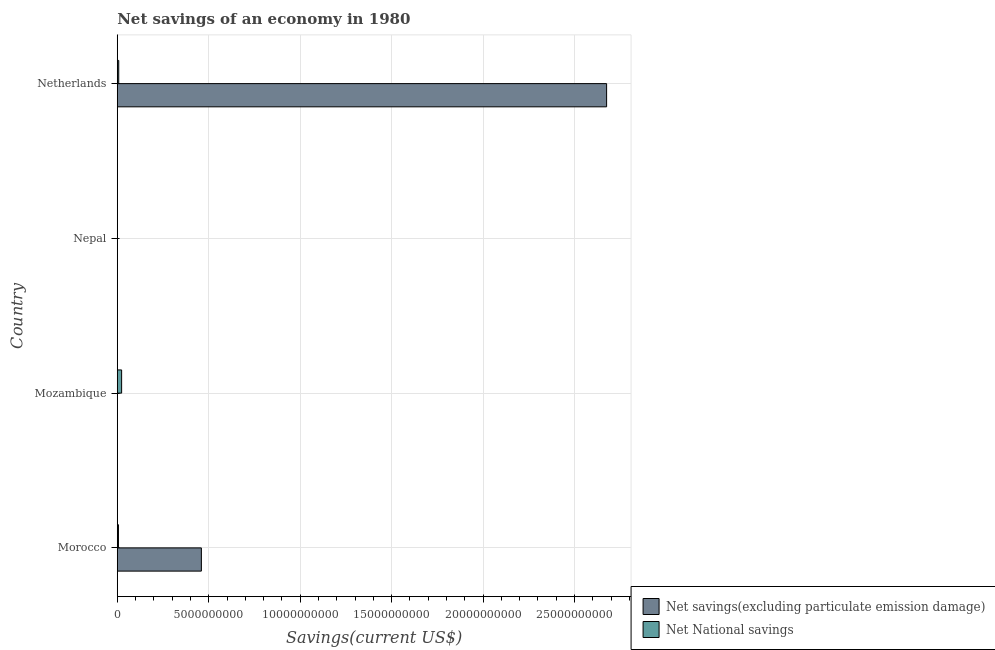Are the number of bars per tick equal to the number of legend labels?
Give a very brief answer. No. Are the number of bars on each tick of the Y-axis equal?
Offer a very short reply. No. What is the label of the 2nd group of bars from the top?
Your response must be concise. Nepal. In how many cases, is the number of bars for a given country not equal to the number of legend labels?
Offer a very short reply. 2. What is the net national savings in Nepal?
Your answer should be compact. 0. Across all countries, what is the maximum net national savings?
Offer a very short reply. 2.38e+08. Across all countries, what is the minimum net savings(excluding particulate emission damage)?
Your answer should be very brief. 0. What is the total net savings(excluding particulate emission damage) in the graph?
Offer a terse response. 3.14e+1. What is the difference between the net national savings in Mozambique and that in Netherlands?
Your response must be concise. 1.58e+08. What is the difference between the net savings(excluding particulate emission damage) in Morocco and the net national savings in Nepal?
Ensure brevity in your answer.  4.60e+09. What is the average net savings(excluding particulate emission damage) per country?
Ensure brevity in your answer.  7.84e+09. What is the difference between the net national savings and net savings(excluding particulate emission damage) in Morocco?
Offer a very short reply. -4.53e+09. In how many countries, is the net national savings greater than 13000000000 US$?
Give a very brief answer. 0. What is the ratio of the net national savings in Morocco to that in Mozambique?
Keep it short and to the point. 0.27. What is the difference between the highest and the second highest net national savings?
Give a very brief answer. 1.58e+08. What is the difference between the highest and the lowest net savings(excluding particulate emission damage)?
Keep it short and to the point. 2.68e+1. Is the sum of the net national savings in Mozambique and Netherlands greater than the maximum net savings(excluding particulate emission damage) across all countries?
Keep it short and to the point. No. How many bars are there?
Your answer should be compact. 5. Are all the bars in the graph horizontal?
Your answer should be very brief. Yes. How many countries are there in the graph?
Give a very brief answer. 4. What is the difference between two consecutive major ticks on the X-axis?
Offer a terse response. 5.00e+09. Does the graph contain any zero values?
Keep it short and to the point. Yes. Where does the legend appear in the graph?
Make the answer very short. Bottom right. How many legend labels are there?
Your response must be concise. 2. How are the legend labels stacked?
Give a very brief answer. Vertical. What is the title of the graph?
Your response must be concise. Net savings of an economy in 1980. What is the label or title of the X-axis?
Provide a succinct answer. Savings(current US$). What is the label or title of the Y-axis?
Your response must be concise. Country. What is the Savings(current US$) in Net savings(excluding particulate emission damage) in Morocco?
Your answer should be very brief. 4.60e+09. What is the Savings(current US$) of Net National savings in Morocco?
Provide a short and direct response. 6.43e+07. What is the Savings(current US$) in Net National savings in Mozambique?
Keep it short and to the point. 2.38e+08. What is the Savings(current US$) of Net savings(excluding particulate emission damage) in Nepal?
Offer a very short reply. 0. What is the Savings(current US$) of Net savings(excluding particulate emission damage) in Netherlands?
Make the answer very short. 2.68e+1. What is the Savings(current US$) in Net National savings in Netherlands?
Provide a succinct answer. 7.94e+07. Across all countries, what is the maximum Savings(current US$) of Net savings(excluding particulate emission damage)?
Provide a succinct answer. 2.68e+1. Across all countries, what is the maximum Savings(current US$) in Net National savings?
Keep it short and to the point. 2.38e+08. Across all countries, what is the minimum Savings(current US$) of Net savings(excluding particulate emission damage)?
Give a very brief answer. 0. Across all countries, what is the minimum Savings(current US$) in Net National savings?
Offer a very short reply. 0. What is the total Savings(current US$) of Net savings(excluding particulate emission damage) in the graph?
Make the answer very short. 3.14e+1. What is the total Savings(current US$) in Net National savings in the graph?
Give a very brief answer. 3.81e+08. What is the difference between the Savings(current US$) in Net National savings in Morocco and that in Mozambique?
Keep it short and to the point. -1.74e+08. What is the difference between the Savings(current US$) in Net savings(excluding particulate emission damage) in Morocco and that in Netherlands?
Your response must be concise. -2.22e+1. What is the difference between the Savings(current US$) in Net National savings in Morocco and that in Netherlands?
Offer a terse response. -1.50e+07. What is the difference between the Savings(current US$) in Net National savings in Mozambique and that in Netherlands?
Offer a terse response. 1.58e+08. What is the difference between the Savings(current US$) in Net savings(excluding particulate emission damage) in Morocco and the Savings(current US$) in Net National savings in Mozambique?
Your response must be concise. 4.36e+09. What is the difference between the Savings(current US$) of Net savings(excluding particulate emission damage) in Morocco and the Savings(current US$) of Net National savings in Netherlands?
Your answer should be very brief. 4.52e+09. What is the average Savings(current US$) of Net savings(excluding particulate emission damage) per country?
Your response must be concise. 7.84e+09. What is the average Savings(current US$) of Net National savings per country?
Provide a short and direct response. 9.54e+07. What is the difference between the Savings(current US$) of Net savings(excluding particulate emission damage) and Savings(current US$) of Net National savings in Morocco?
Your answer should be very brief. 4.53e+09. What is the difference between the Savings(current US$) of Net savings(excluding particulate emission damage) and Savings(current US$) of Net National savings in Netherlands?
Keep it short and to the point. 2.67e+1. What is the ratio of the Savings(current US$) of Net National savings in Morocco to that in Mozambique?
Your response must be concise. 0.27. What is the ratio of the Savings(current US$) in Net savings(excluding particulate emission damage) in Morocco to that in Netherlands?
Ensure brevity in your answer.  0.17. What is the ratio of the Savings(current US$) of Net National savings in Morocco to that in Netherlands?
Your response must be concise. 0.81. What is the ratio of the Savings(current US$) of Net National savings in Mozambique to that in Netherlands?
Your response must be concise. 3. What is the difference between the highest and the second highest Savings(current US$) in Net National savings?
Keep it short and to the point. 1.58e+08. What is the difference between the highest and the lowest Savings(current US$) of Net savings(excluding particulate emission damage)?
Provide a short and direct response. 2.68e+1. What is the difference between the highest and the lowest Savings(current US$) of Net National savings?
Your response must be concise. 2.38e+08. 